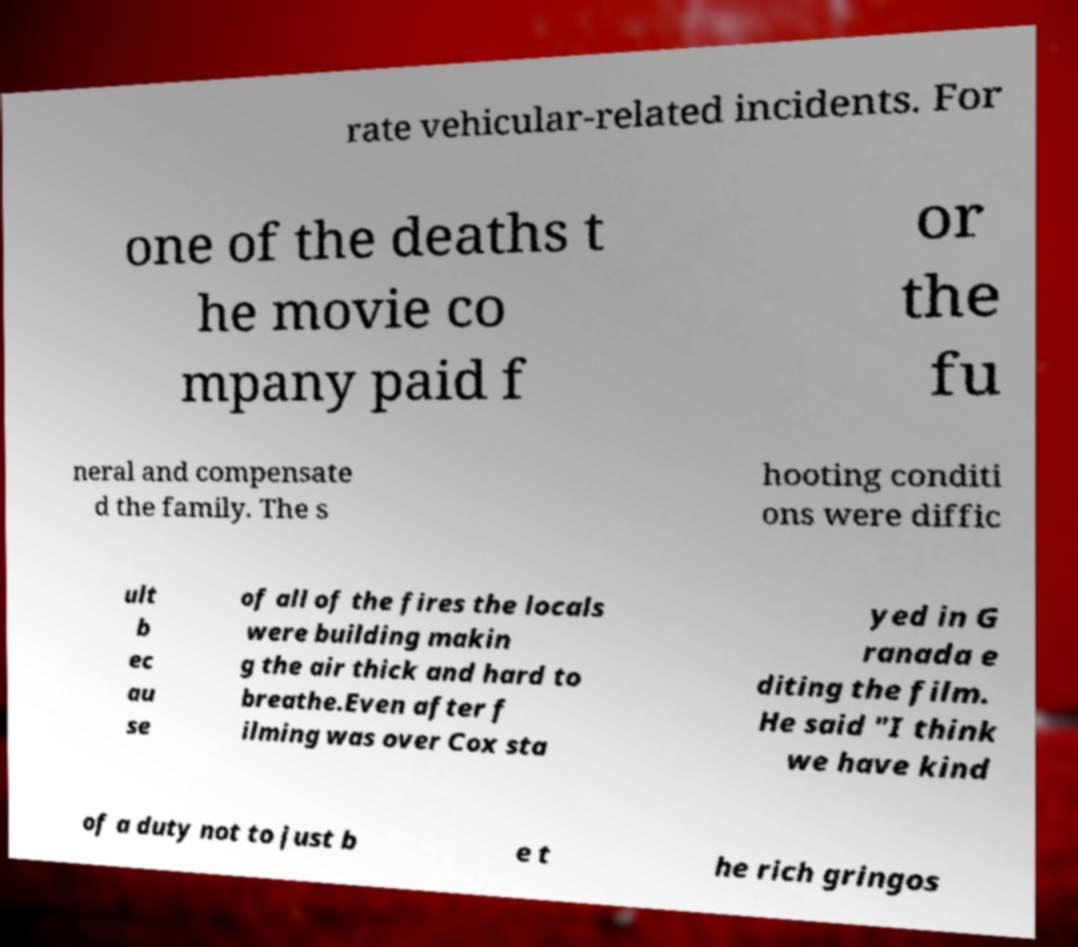Could you assist in decoding the text presented in this image and type it out clearly? rate vehicular-related incidents. For one of the deaths t he movie co mpany paid f or the fu neral and compensate d the family. The s hooting conditi ons were diffic ult b ec au se of all of the fires the locals were building makin g the air thick and hard to breathe.Even after f ilming was over Cox sta yed in G ranada e diting the film. He said "I think we have kind of a duty not to just b e t he rich gringos 